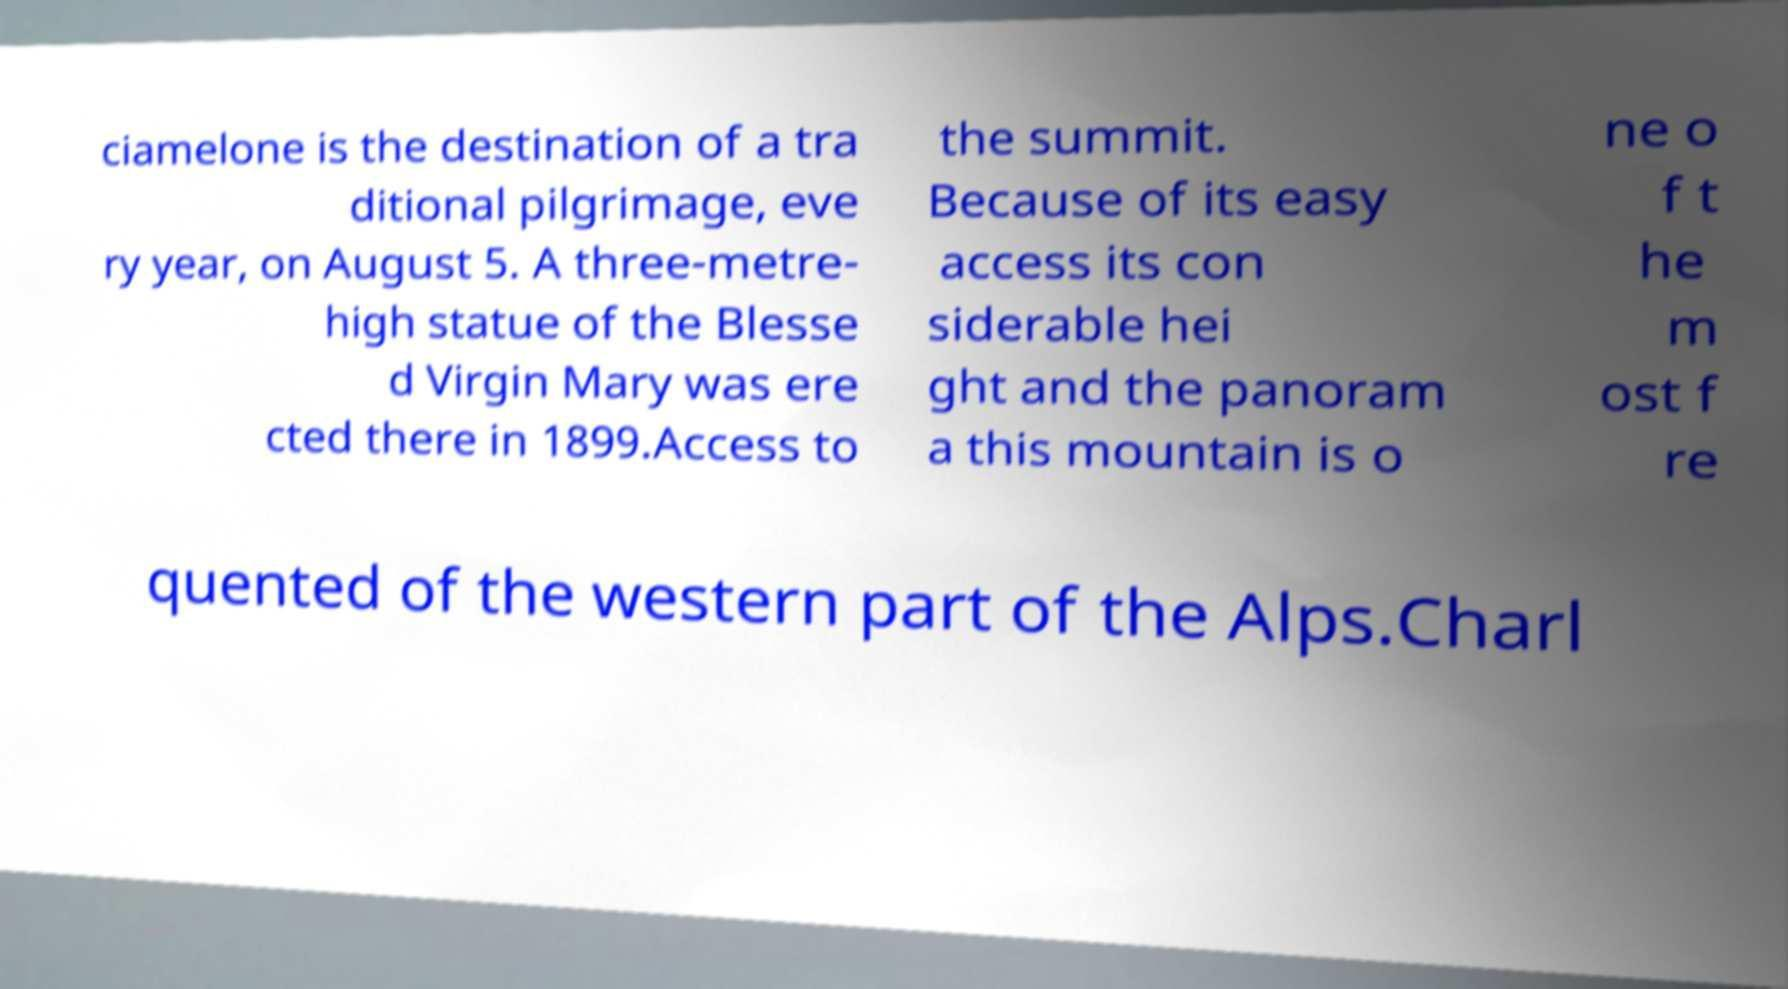Could you assist in decoding the text presented in this image and type it out clearly? ciamelone is the destination of a tra ditional pilgrimage, eve ry year, on August 5. A three-metre- high statue of the Blesse d Virgin Mary was ere cted there in 1899.Access to the summit. Because of its easy access its con siderable hei ght and the panoram a this mountain is o ne o f t he m ost f re quented of the western part of the Alps.Charl 